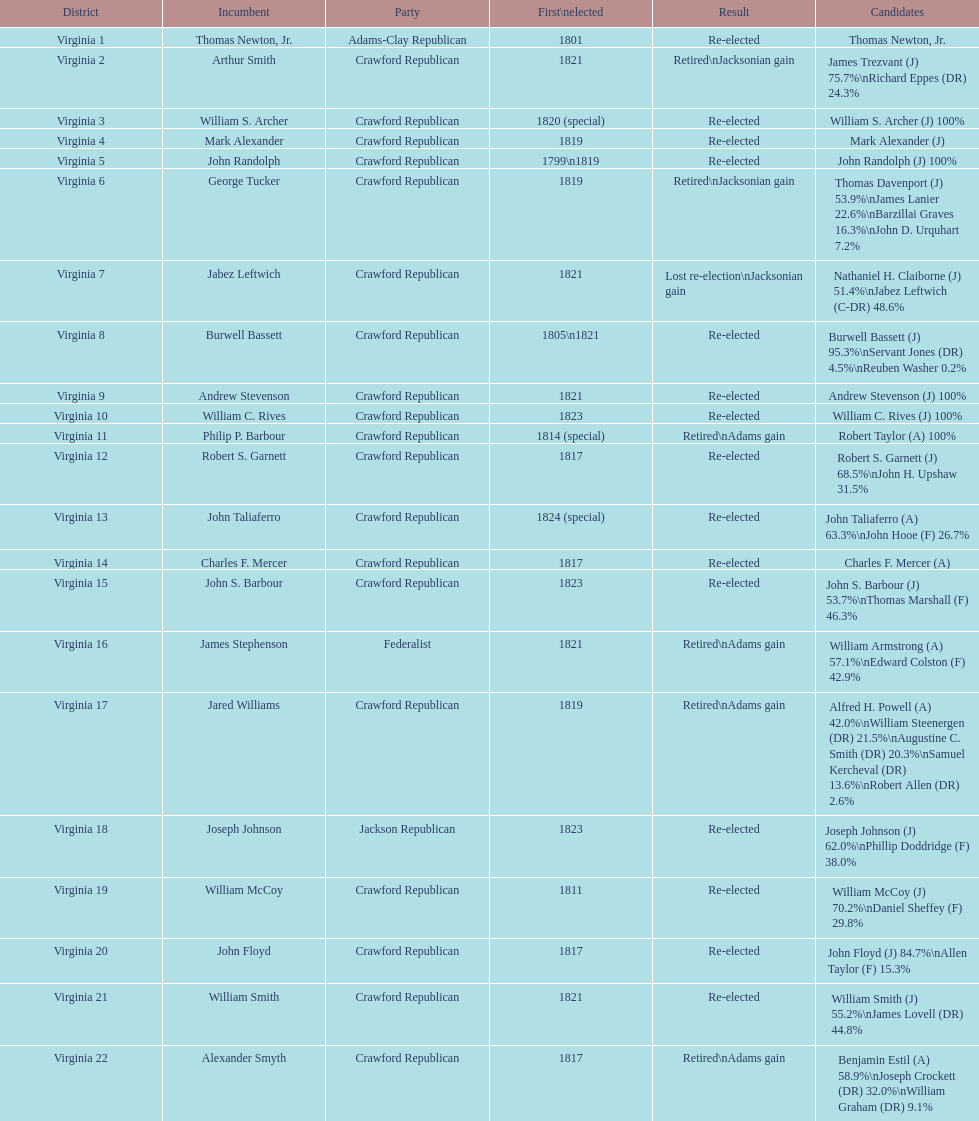Name the only candidate that was first elected in 1811. William McCoy. Parse the table in full. {'header': ['District', 'Incumbent', 'Party', 'First\\nelected', 'Result', 'Candidates'], 'rows': [['Virginia 1', 'Thomas Newton, Jr.', 'Adams-Clay Republican', '1801', 'Re-elected', 'Thomas Newton, Jr.'], ['Virginia 2', 'Arthur Smith', 'Crawford Republican', '1821', 'Retired\\nJacksonian gain', 'James Trezvant (J) 75.7%\\nRichard Eppes (DR) 24.3%'], ['Virginia 3', 'William S. Archer', 'Crawford Republican', '1820 (special)', 'Re-elected', 'William S. Archer (J) 100%'], ['Virginia 4', 'Mark Alexander', 'Crawford Republican', '1819', 'Re-elected', 'Mark Alexander (J)'], ['Virginia 5', 'John Randolph', 'Crawford Republican', '1799\\n1819', 'Re-elected', 'John Randolph (J) 100%'], ['Virginia 6', 'George Tucker', 'Crawford Republican', '1819', 'Retired\\nJacksonian gain', 'Thomas Davenport (J) 53.9%\\nJames Lanier 22.6%\\nBarzillai Graves 16.3%\\nJohn D. Urquhart 7.2%'], ['Virginia 7', 'Jabez Leftwich', 'Crawford Republican', '1821', 'Lost re-election\\nJacksonian gain', 'Nathaniel H. Claiborne (J) 51.4%\\nJabez Leftwich (C-DR) 48.6%'], ['Virginia 8', 'Burwell Bassett', 'Crawford Republican', '1805\\n1821', 'Re-elected', 'Burwell Bassett (J) 95.3%\\nServant Jones (DR) 4.5%\\nReuben Washer 0.2%'], ['Virginia 9', 'Andrew Stevenson', 'Crawford Republican', '1821', 'Re-elected', 'Andrew Stevenson (J) 100%'], ['Virginia 10', 'William C. Rives', 'Crawford Republican', '1823', 'Re-elected', 'William C. Rives (J) 100%'], ['Virginia 11', 'Philip P. Barbour', 'Crawford Republican', '1814 (special)', 'Retired\\nAdams gain', 'Robert Taylor (A) 100%'], ['Virginia 12', 'Robert S. Garnett', 'Crawford Republican', '1817', 'Re-elected', 'Robert S. Garnett (J) 68.5%\\nJohn H. Upshaw 31.5%'], ['Virginia 13', 'John Taliaferro', 'Crawford Republican', '1824 (special)', 'Re-elected', 'John Taliaferro (A) 63.3%\\nJohn Hooe (F) 26.7%'], ['Virginia 14', 'Charles F. Mercer', 'Crawford Republican', '1817', 'Re-elected', 'Charles F. Mercer (A)'], ['Virginia 15', 'John S. Barbour', 'Crawford Republican', '1823', 'Re-elected', 'John S. Barbour (J) 53.7%\\nThomas Marshall (F) 46.3%'], ['Virginia 16', 'James Stephenson', 'Federalist', '1821', 'Retired\\nAdams gain', 'William Armstrong (A) 57.1%\\nEdward Colston (F) 42.9%'], ['Virginia 17', 'Jared Williams', 'Crawford Republican', '1819', 'Retired\\nAdams gain', 'Alfred H. Powell (A) 42.0%\\nWilliam Steenergen (DR) 21.5%\\nAugustine C. Smith (DR) 20.3%\\nSamuel Kercheval (DR) 13.6%\\nRobert Allen (DR) 2.6%'], ['Virginia 18', 'Joseph Johnson', 'Jackson Republican', '1823', 'Re-elected', 'Joseph Johnson (J) 62.0%\\nPhillip Doddridge (F) 38.0%'], ['Virginia 19', 'William McCoy', 'Crawford Republican', '1811', 'Re-elected', 'William McCoy (J) 70.2%\\nDaniel Sheffey (F) 29.8%'], ['Virginia 20', 'John Floyd', 'Crawford Republican', '1817', 'Re-elected', 'John Floyd (J) 84.7%\\nAllen Taylor (F) 15.3%'], ['Virginia 21', 'William Smith', 'Crawford Republican', '1821', 'Re-elected', 'William Smith (J) 55.2%\\nJames Lovell (DR) 44.8%'], ['Virginia 22', 'Alexander Smyth', 'Crawford Republican', '1817', 'Retired\\nAdams gain', 'Benjamin Estil (A) 58.9%\\nJoseph Crockett (DR) 32.0%\\nWilliam Graham (DR) 9.1%']]} 